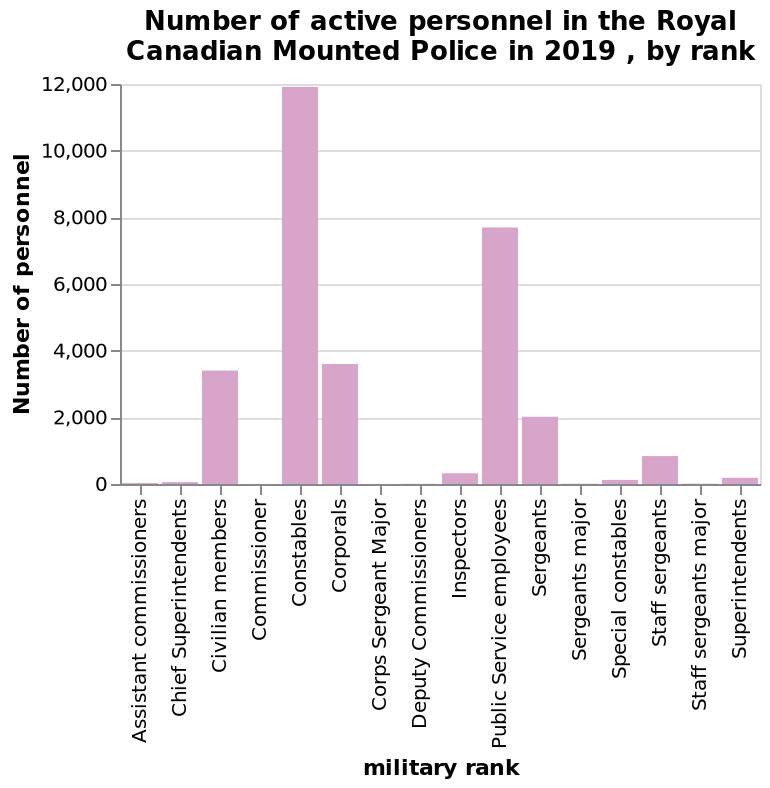<image>
please summary the statistics and relations of the chart You can see that the most active personnel are the constables who account for 12,000. You can also see that the second highest active personnel is taken up by the public service employees. There are also 6 military ranks that currently have no active personnel. What are the categories on the x-axis? The categories on the x-axis range from "Assistant commissioners" to "Superintendents". What is the range of the y-axis scale?  The range of the y-axis scale is from 0 to 12,000. What is the title of the bar chart?  The title of the bar chart is "Number of active personnel in the Royal Canadian Mounted Police in 2019, by rank." 